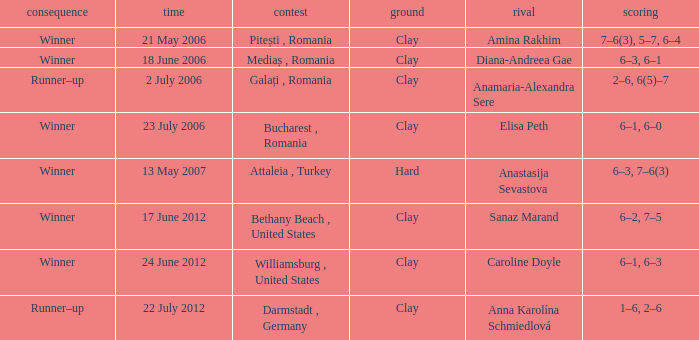What was the score in the match against Sanaz Marand? 6–2, 7–5. 